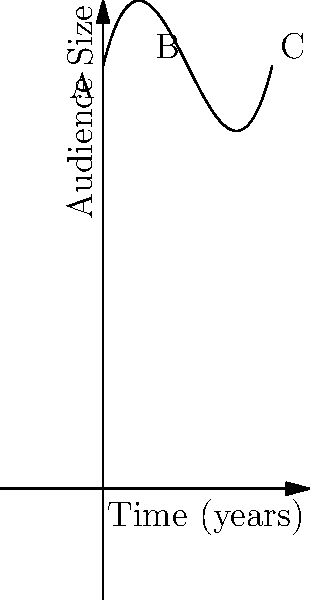During your coverage of Wes Montgomery's concerts, you noticed a trend in audience growth over time. The polynomial function $f(x) = 0.5x^3 - 3x^2 + 4x + 10$ represents this growth, where $x$ is the time in years and $f(x)$ is the audience size in thousands. Based on the graph, at which point does the audience growth rate start to increase again after an initial slowdown? To answer this question, we need to analyze the behavior of the polynomial function:

1. The curve starts at point A (0,10), indicating an initial audience of 10,000.

2. As we move along the curve, we see that it rises, then starts to level off around point B.

3. The growth rate is represented by the slope of the curve. A decreasing growth rate is shown by a decreasing slope (concave down), while an increasing growth rate is shown by an increasing slope (concave up).

4. The point where the growth rate changes from decreasing to increasing is called an inflection point. This is where the curve changes from concave down to concave up.

5. On the graph, we can see that this inflection point occurs at point B, which appears to be around x = 2 (2 years).

6. After point B, the curve becomes steeper, indicating that the audience growth rate is increasing again.

Therefore, the audience growth rate starts to increase again after an initial slowdown at point B, which is approximately 2 years into the time period shown on the graph.
Answer: 2 years 